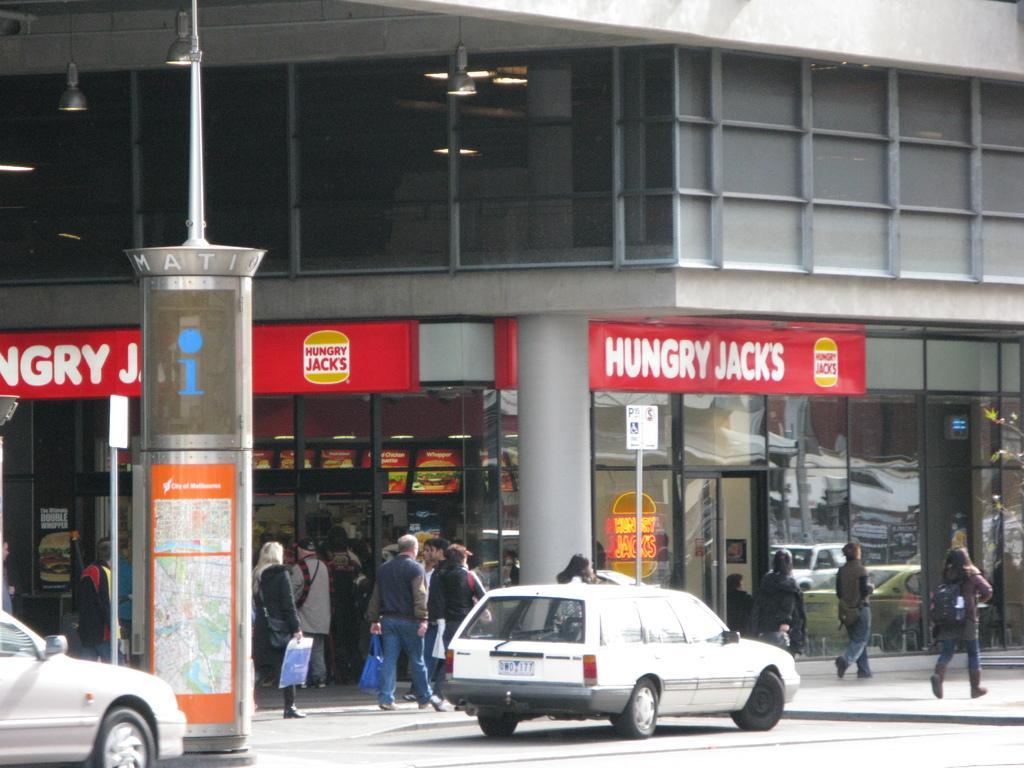Could you give a brief overview of what you see in this image? In the center of the image we can see two vehicles on the road. In the background there is a building, lights, boards with some text, pillars, few people are walking, few people are holding some objects and a few other objects. 